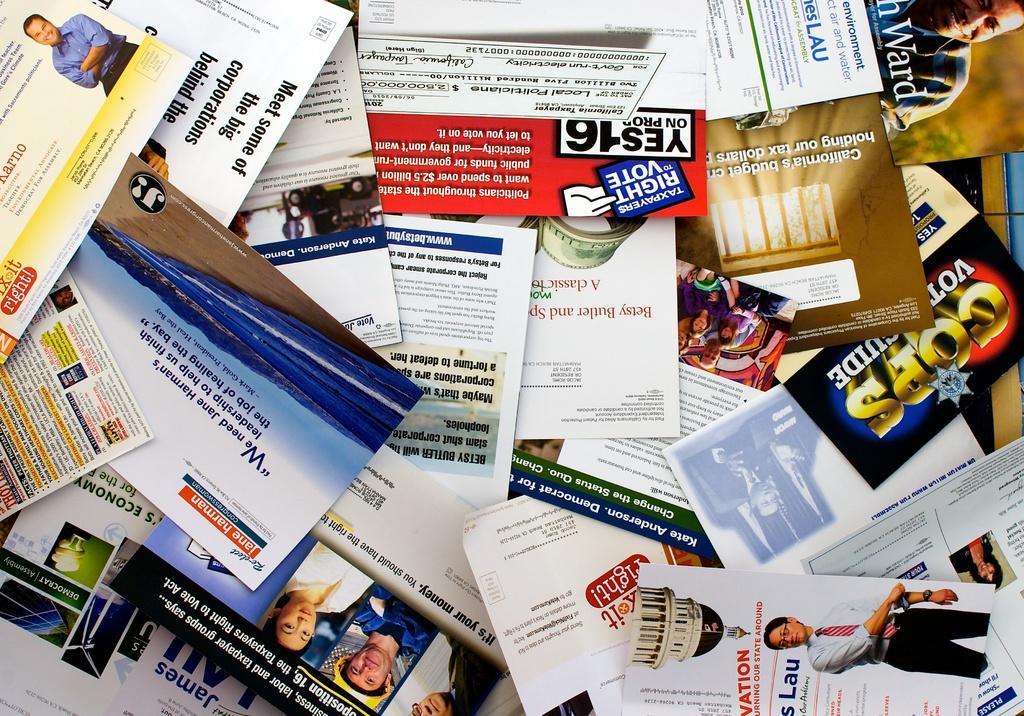Please provide a concise description of this image. In this image, I think these are the pamphlets, which are one upon the other. I can see the pictures, letters, logos on the pamphlets. 